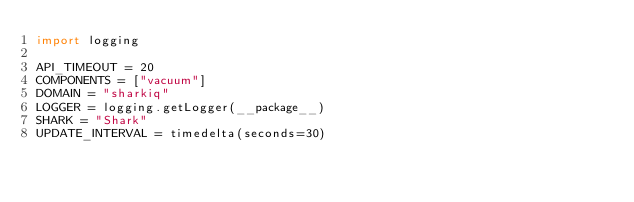Convert code to text. <code><loc_0><loc_0><loc_500><loc_500><_Python_>import logging

API_TIMEOUT = 20
COMPONENTS = ["vacuum"]
DOMAIN = "sharkiq"
LOGGER = logging.getLogger(__package__)
SHARK = "Shark"
UPDATE_INTERVAL = timedelta(seconds=30)
</code> 